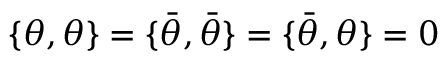Convert formula to latex. <formula><loc_0><loc_0><loc_500><loc_500>\{ \theta , \theta \} = \{ { \bar { \theta } } , { \bar { \theta } } \} = \{ { \bar { \theta } } , \theta \} = 0</formula> 